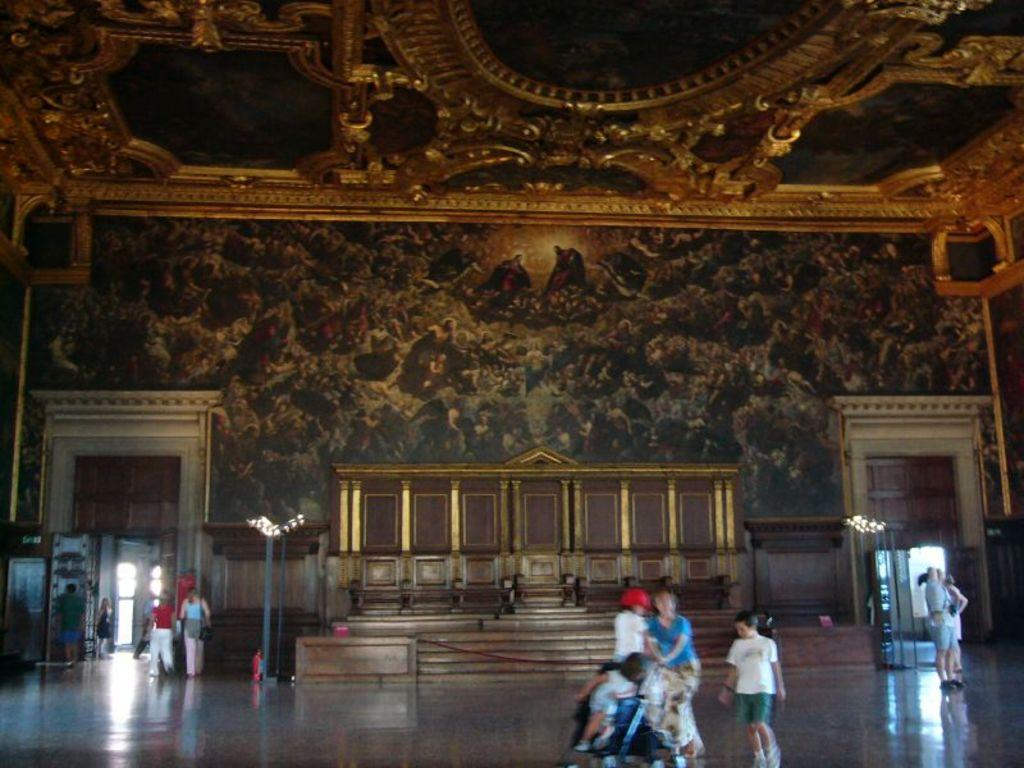What are the people in the image doing? There are persons standing, walking, and sitting in the image. What can be seen in the background of the image? There is a wall in the background of the image, and there is a painting on the wall. What architectural features are present in the image? There are doors in the image. What type of snow can be seen falling in the image? There is no snow present in the image. Can you describe the goat that is interacting with the persons in the image? There are no goats present in the image; only people are visible. 